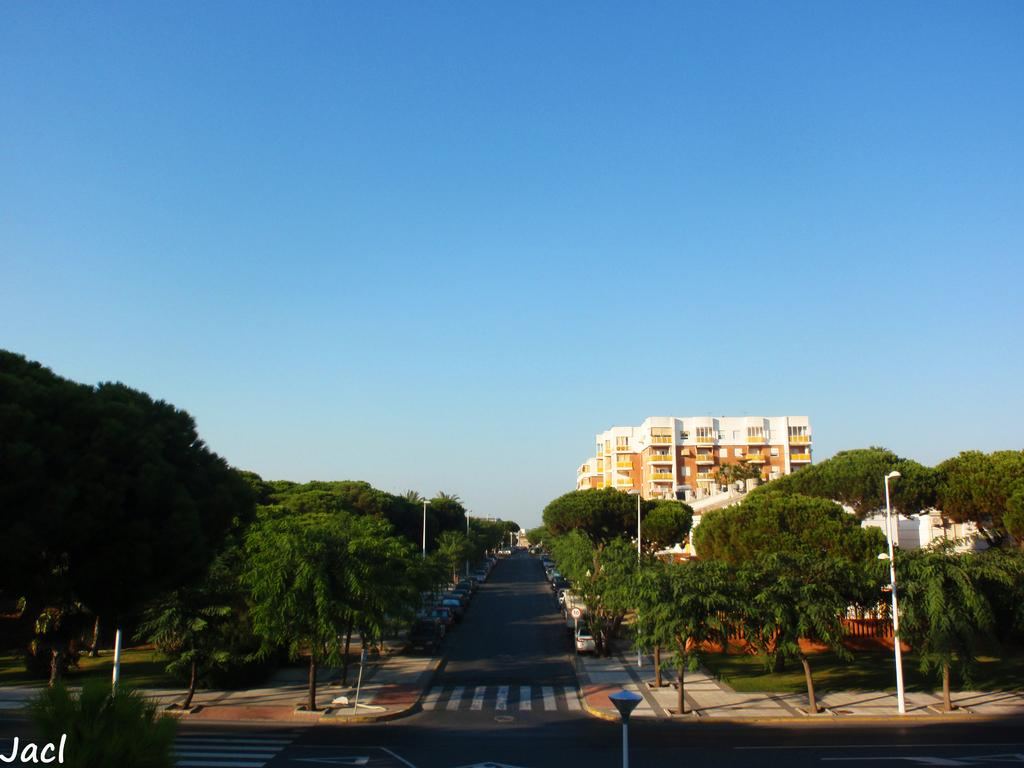What is the main subject in the foreground of the image? There is a group of cars in the foreground of the image. Where are the cars located? The cars are placed on the road. What can be seen in the background of the image? There are trees, buildings, poles, and the sky visible in the background of the image. What type of vein is visible in the image? There is no vein visible in the image; it features a group of cars on the road with various background elements. 